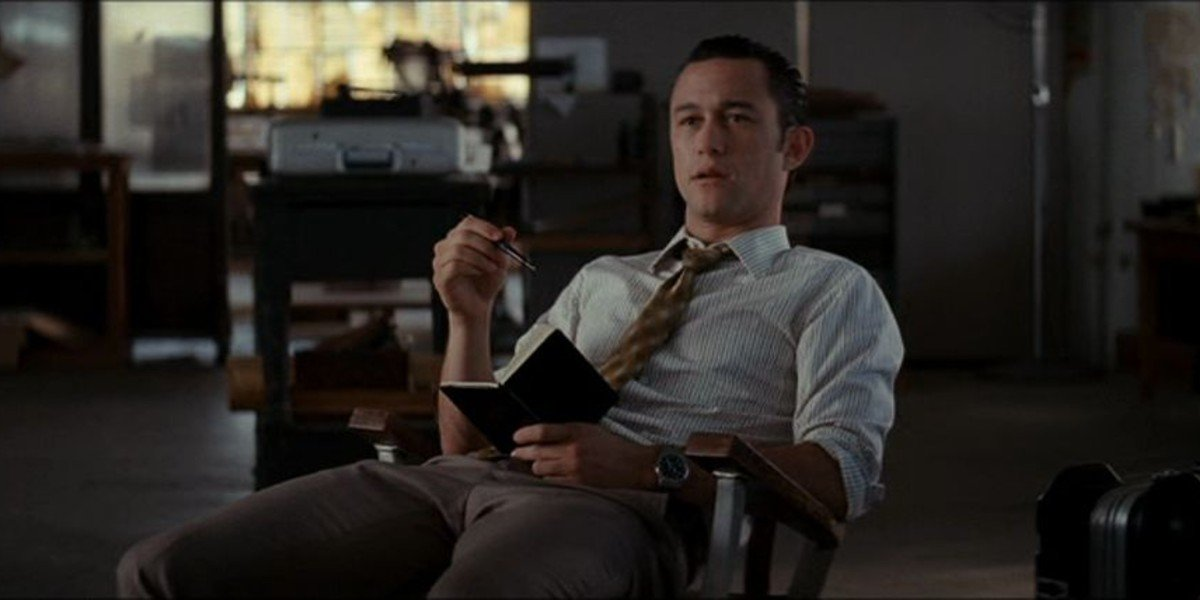Can you describe the main features of this image for me? This image captures a moment featuring a well-dressed man absorbed in deep thought. He is comfortably seated in a wooden chair in what appears to be an office setting. He wears a crisp white shirt paired with a vibrant yellow tie and gray trousers, exuding a sense of professionalism. In his right hand, he holds a black book, potentially filled with important notes or scripts, and he seems ready to jot down thoughts with the pen in his left hand. His gaze is directed off to the side, giving him a contemplative look. The background includes a desk and a window, typical of a workspace, and there is also a suitcase, suggesting a busy schedule or upcoming travel. His thoughtful expression contributes to the overall pensive mood of the scene. 